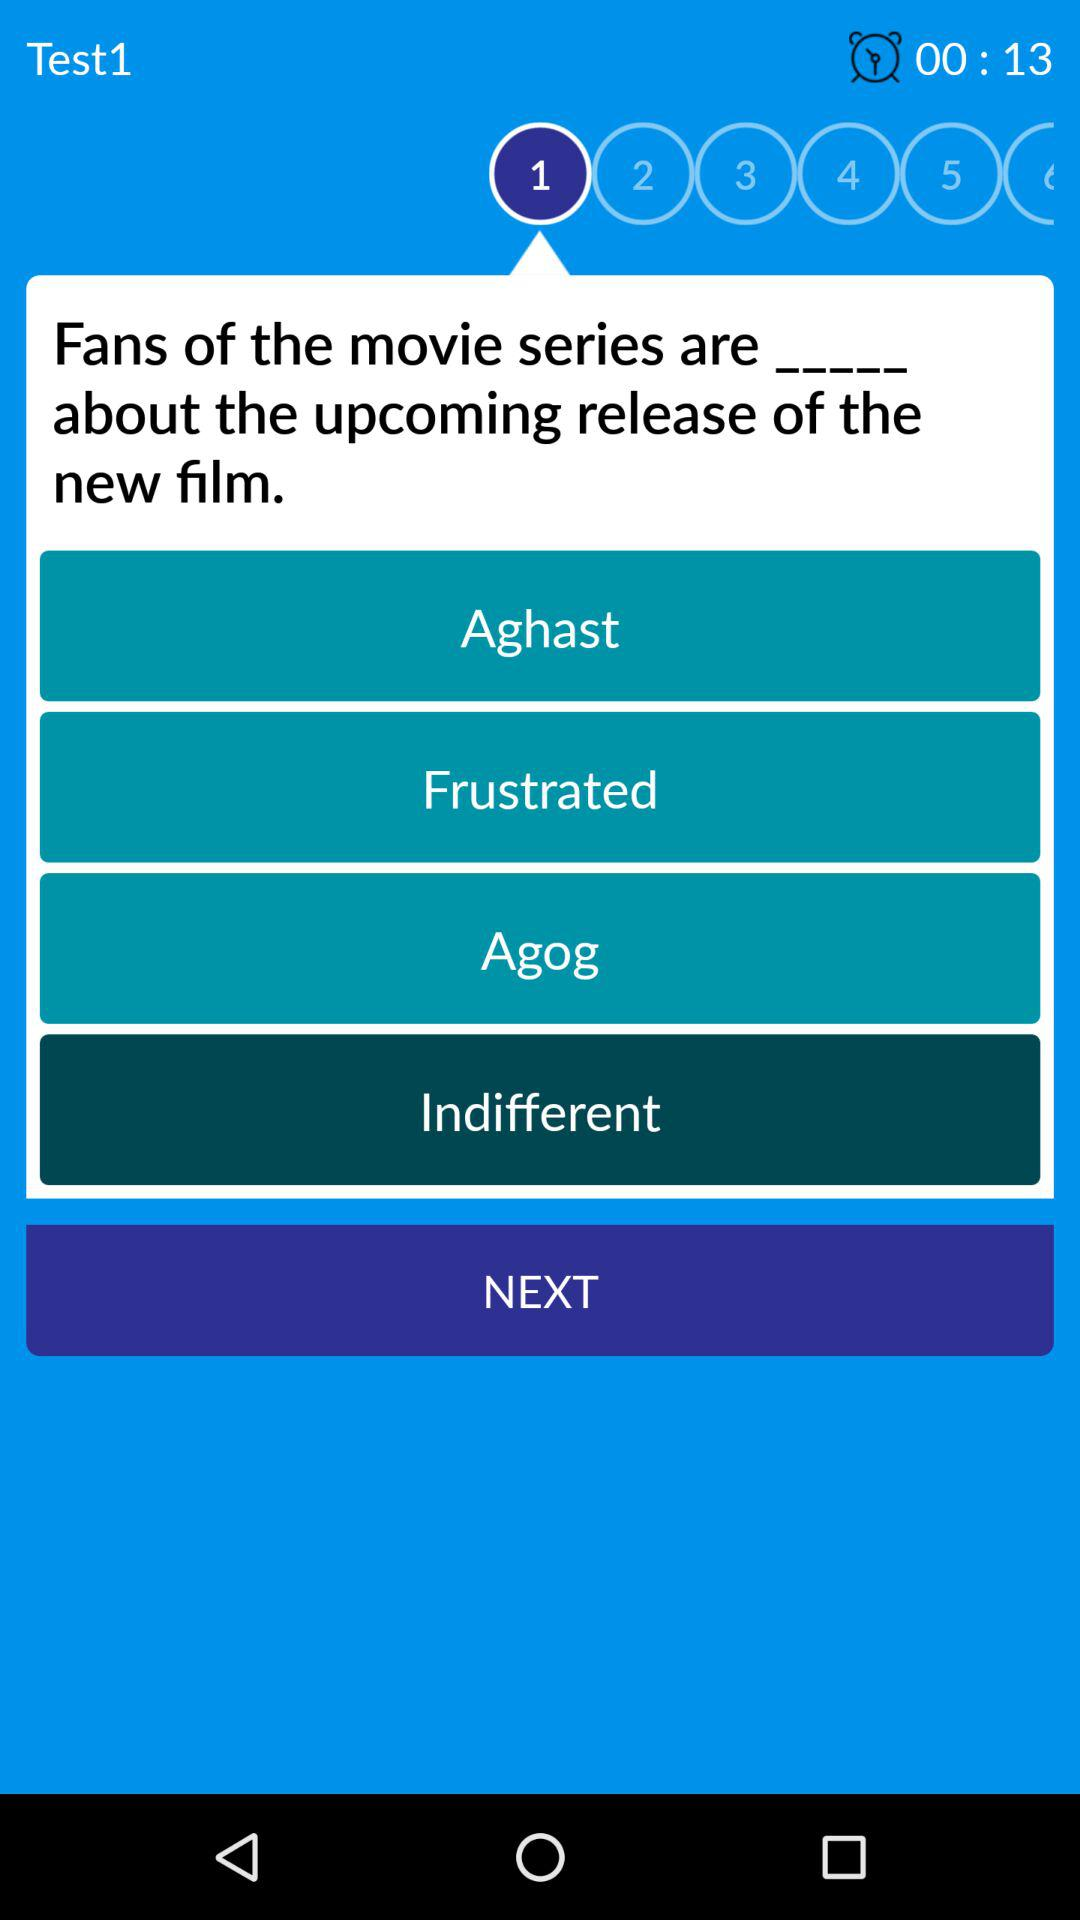What is the question that is displayed? The question is "Fans of the movie series are _____ about the upcoming release of the new film.". 